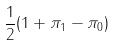Convert formula to latex. <formula><loc_0><loc_0><loc_500><loc_500>\frac { 1 } { 2 } ( 1 + \pi _ { 1 } - \pi _ { 0 } )</formula> 